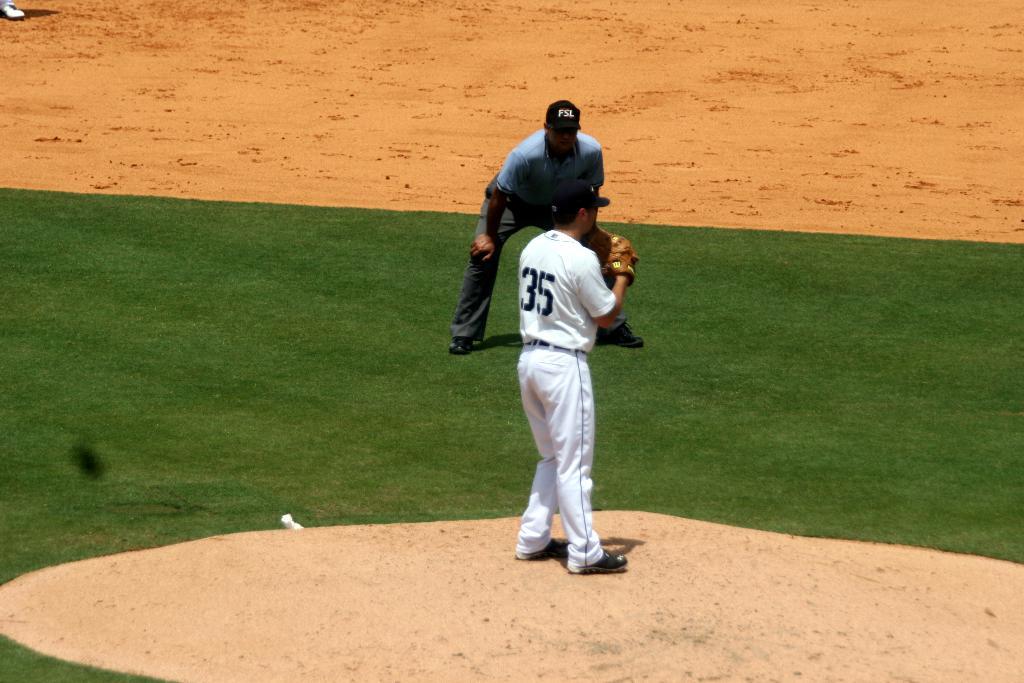What number is the pitcher?
Your response must be concise. 35. What does the referee have advertised on his hat?
Provide a succinct answer. Fsl. 